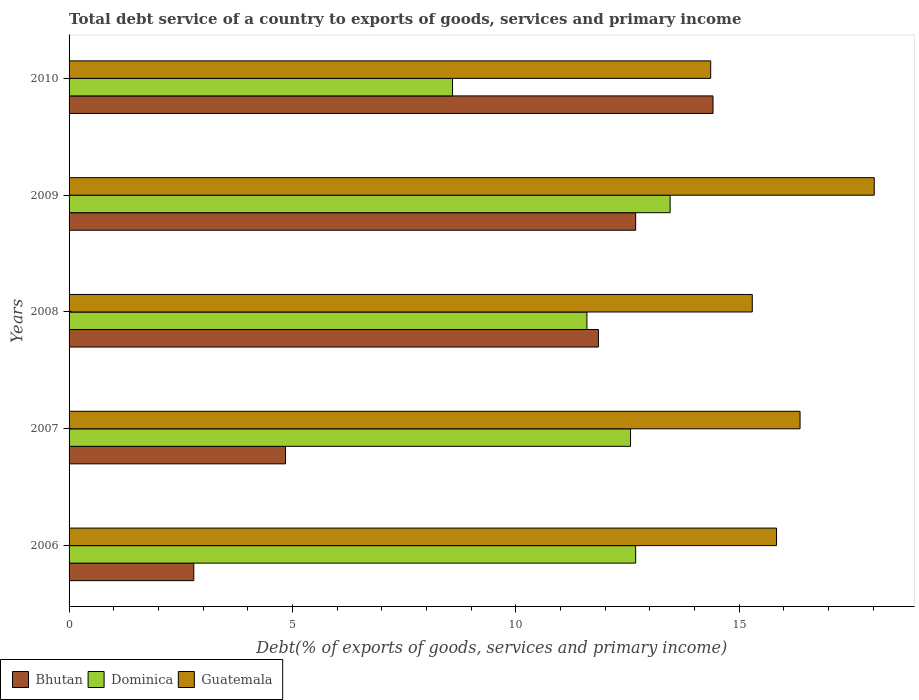Are the number of bars per tick equal to the number of legend labels?
Provide a short and direct response. Yes. Are the number of bars on each tick of the Y-axis equal?
Provide a succinct answer. Yes. How many bars are there on the 3rd tick from the bottom?
Your response must be concise. 3. What is the label of the 4th group of bars from the top?
Offer a very short reply. 2007. What is the total debt service in Dominica in 2007?
Offer a very short reply. 12.57. Across all years, what is the maximum total debt service in Bhutan?
Provide a succinct answer. 14.42. Across all years, what is the minimum total debt service in Bhutan?
Keep it short and to the point. 2.79. In which year was the total debt service in Dominica maximum?
Ensure brevity in your answer.  2009. What is the total total debt service in Bhutan in the graph?
Offer a terse response. 46.59. What is the difference between the total debt service in Dominica in 2008 and that in 2009?
Give a very brief answer. -1.86. What is the difference between the total debt service in Bhutan in 2009 and the total debt service in Guatemala in 2007?
Provide a short and direct response. -3.68. What is the average total debt service in Dominica per year?
Offer a very short reply. 11.78. In the year 2007, what is the difference between the total debt service in Bhutan and total debt service in Dominica?
Provide a succinct answer. -7.72. In how many years, is the total debt service in Guatemala greater than 14 %?
Your response must be concise. 5. What is the ratio of the total debt service in Guatemala in 2006 to that in 2008?
Your answer should be very brief. 1.04. What is the difference between the highest and the second highest total debt service in Bhutan?
Ensure brevity in your answer.  1.73. What is the difference between the highest and the lowest total debt service in Bhutan?
Provide a succinct answer. 11.62. In how many years, is the total debt service in Guatemala greater than the average total debt service in Guatemala taken over all years?
Offer a very short reply. 2. Is the sum of the total debt service in Guatemala in 2008 and 2009 greater than the maximum total debt service in Dominica across all years?
Ensure brevity in your answer.  Yes. What does the 2nd bar from the top in 2009 represents?
Offer a very short reply. Dominica. What does the 3rd bar from the bottom in 2008 represents?
Give a very brief answer. Guatemala. Is it the case that in every year, the sum of the total debt service in Bhutan and total debt service in Dominica is greater than the total debt service in Guatemala?
Your response must be concise. No. How many bars are there?
Offer a terse response. 15. Are all the bars in the graph horizontal?
Ensure brevity in your answer.  Yes. How many years are there in the graph?
Give a very brief answer. 5. What is the difference between two consecutive major ticks on the X-axis?
Your response must be concise. 5. Does the graph contain any zero values?
Your answer should be compact. No. Does the graph contain grids?
Your answer should be compact. No. Where does the legend appear in the graph?
Make the answer very short. Bottom left. What is the title of the graph?
Offer a very short reply. Total debt service of a country to exports of goods, services and primary income. What is the label or title of the X-axis?
Offer a terse response. Debt(% of exports of goods, services and primary income). What is the Debt(% of exports of goods, services and primary income) in Bhutan in 2006?
Provide a succinct answer. 2.79. What is the Debt(% of exports of goods, services and primary income) in Dominica in 2006?
Ensure brevity in your answer.  12.68. What is the Debt(% of exports of goods, services and primary income) of Guatemala in 2006?
Provide a short and direct response. 15.84. What is the Debt(% of exports of goods, services and primary income) of Bhutan in 2007?
Give a very brief answer. 4.85. What is the Debt(% of exports of goods, services and primary income) in Dominica in 2007?
Your answer should be very brief. 12.57. What is the Debt(% of exports of goods, services and primary income) of Guatemala in 2007?
Your answer should be compact. 16.36. What is the Debt(% of exports of goods, services and primary income) in Bhutan in 2008?
Your answer should be very brief. 11.85. What is the Debt(% of exports of goods, services and primary income) of Dominica in 2008?
Provide a short and direct response. 11.59. What is the Debt(% of exports of goods, services and primary income) of Guatemala in 2008?
Give a very brief answer. 15.3. What is the Debt(% of exports of goods, services and primary income) of Bhutan in 2009?
Offer a terse response. 12.68. What is the Debt(% of exports of goods, services and primary income) of Dominica in 2009?
Your response must be concise. 13.46. What is the Debt(% of exports of goods, services and primary income) in Guatemala in 2009?
Provide a short and direct response. 18.03. What is the Debt(% of exports of goods, services and primary income) of Bhutan in 2010?
Offer a terse response. 14.42. What is the Debt(% of exports of goods, services and primary income) of Dominica in 2010?
Your response must be concise. 8.58. What is the Debt(% of exports of goods, services and primary income) of Guatemala in 2010?
Make the answer very short. 14.36. Across all years, what is the maximum Debt(% of exports of goods, services and primary income) in Bhutan?
Provide a succinct answer. 14.42. Across all years, what is the maximum Debt(% of exports of goods, services and primary income) in Dominica?
Your answer should be very brief. 13.46. Across all years, what is the maximum Debt(% of exports of goods, services and primary income) of Guatemala?
Ensure brevity in your answer.  18.03. Across all years, what is the minimum Debt(% of exports of goods, services and primary income) of Bhutan?
Provide a succinct answer. 2.79. Across all years, what is the minimum Debt(% of exports of goods, services and primary income) of Dominica?
Your answer should be very brief. 8.58. Across all years, what is the minimum Debt(% of exports of goods, services and primary income) of Guatemala?
Your answer should be very brief. 14.36. What is the total Debt(% of exports of goods, services and primary income) in Bhutan in the graph?
Your answer should be very brief. 46.59. What is the total Debt(% of exports of goods, services and primary income) of Dominica in the graph?
Your answer should be compact. 58.89. What is the total Debt(% of exports of goods, services and primary income) in Guatemala in the graph?
Offer a terse response. 79.89. What is the difference between the Debt(% of exports of goods, services and primary income) of Bhutan in 2006 and that in 2007?
Keep it short and to the point. -2.05. What is the difference between the Debt(% of exports of goods, services and primary income) of Dominica in 2006 and that in 2007?
Offer a very short reply. 0.11. What is the difference between the Debt(% of exports of goods, services and primary income) of Guatemala in 2006 and that in 2007?
Provide a succinct answer. -0.53. What is the difference between the Debt(% of exports of goods, services and primary income) of Bhutan in 2006 and that in 2008?
Your answer should be compact. -9.06. What is the difference between the Debt(% of exports of goods, services and primary income) of Guatemala in 2006 and that in 2008?
Your answer should be very brief. 0.54. What is the difference between the Debt(% of exports of goods, services and primary income) of Bhutan in 2006 and that in 2009?
Your response must be concise. -9.89. What is the difference between the Debt(% of exports of goods, services and primary income) of Dominica in 2006 and that in 2009?
Offer a very short reply. -0.77. What is the difference between the Debt(% of exports of goods, services and primary income) in Guatemala in 2006 and that in 2009?
Make the answer very short. -2.19. What is the difference between the Debt(% of exports of goods, services and primary income) in Bhutan in 2006 and that in 2010?
Keep it short and to the point. -11.62. What is the difference between the Debt(% of exports of goods, services and primary income) in Dominica in 2006 and that in 2010?
Your answer should be very brief. 4.1. What is the difference between the Debt(% of exports of goods, services and primary income) in Guatemala in 2006 and that in 2010?
Provide a short and direct response. 1.47. What is the difference between the Debt(% of exports of goods, services and primary income) in Bhutan in 2007 and that in 2008?
Ensure brevity in your answer.  -7. What is the difference between the Debt(% of exports of goods, services and primary income) in Dominica in 2007 and that in 2008?
Offer a terse response. 0.98. What is the difference between the Debt(% of exports of goods, services and primary income) of Guatemala in 2007 and that in 2008?
Provide a short and direct response. 1.07. What is the difference between the Debt(% of exports of goods, services and primary income) in Bhutan in 2007 and that in 2009?
Give a very brief answer. -7.84. What is the difference between the Debt(% of exports of goods, services and primary income) of Dominica in 2007 and that in 2009?
Your answer should be very brief. -0.89. What is the difference between the Debt(% of exports of goods, services and primary income) of Guatemala in 2007 and that in 2009?
Ensure brevity in your answer.  -1.66. What is the difference between the Debt(% of exports of goods, services and primary income) of Bhutan in 2007 and that in 2010?
Keep it short and to the point. -9.57. What is the difference between the Debt(% of exports of goods, services and primary income) of Dominica in 2007 and that in 2010?
Offer a terse response. 3.99. What is the difference between the Debt(% of exports of goods, services and primary income) of Guatemala in 2007 and that in 2010?
Provide a short and direct response. 2. What is the difference between the Debt(% of exports of goods, services and primary income) in Bhutan in 2008 and that in 2009?
Provide a short and direct response. -0.83. What is the difference between the Debt(% of exports of goods, services and primary income) in Dominica in 2008 and that in 2009?
Provide a short and direct response. -1.86. What is the difference between the Debt(% of exports of goods, services and primary income) of Guatemala in 2008 and that in 2009?
Your answer should be very brief. -2.73. What is the difference between the Debt(% of exports of goods, services and primary income) of Bhutan in 2008 and that in 2010?
Make the answer very short. -2.57. What is the difference between the Debt(% of exports of goods, services and primary income) of Dominica in 2008 and that in 2010?
Your answer should be very brief. 3.01. What is the difference between the Debt(% of exports of goods, services and primary income) of Guatemala in 2008 and that in 2010?
Your answer should be very brief. 0.93. What is the difference between the Debt(% of exports of goods, services and primary income) in Bhutan in 2009 and that in 2010?
Your response must be concise. -1.73. What is the difference between the Debt(% of exports of goods, services and primary income) in Dominica in 2009 and that in 2010?
Make the answer very short. 4.87. What is the difference between the Debt(% of exports of goods, services and primary income) of Guatemala in 2009 and that in 2010?
Offer a very short reply. 3.66. What is the difference between the Debt(% of exports of goods, services and primary income) in Bhutan in 2006 and the Debt(% of exports of goods, services and primary income) in Dominica in 2007?
Your answer should be compact. -9.78. What is the difference between the Debt(% of exports of goods, services and primary income) in Bhutan in 2006 and the Debt(% of exports of goods, services and primary income) in Guatemala in 2007?
Your response must be concise. -13.57. What is the difference between the Debt(% of exports of goods, services and primary income) in Dominica in 2006 and the Debt(% of exports of goods, services and primary income) in Guatemala in 2007?
Your answer should be very brief. -3.68. What is the difference between the Debt(% of exports of goods, services and primary income) of Bhutan in 2006 and the Debt(% of exports of goods, services and primary income) of Dominica in 2008?
Your answer should be very brief. -8.8. What is the difference between the Debt(% of exports of goods, services and primary income) of Bhutan in 2006 and the Debt(% of exports of goods, services and primary income) of Guatemala in 2008?
Offer a terse response. -12.5. What is the difference between the Debt(% of exports of goods, services and primary income) in Dominica in 2006 and the Debt(% of exports of goods, services and primary income) in Guatemala in 2008?
Your response must be concise. -2.61. What is the difference between the Debt(% of exports of goods, services and primary income) of Bhutan in 2006 and the Debt(% of exports of goods, services and primary income) of Dominica in 2009?
Your response must be concise. -10.66. What is the difference between the Debt(% of exports of goods, services and primary income) of Bhutan in 2006 and the Debt(% of exports of goods, services and primary income) of Guatemala in 2009?
Give a very brief answer. -15.23. What is the difference between the Debt(% of exports of goods, services and primary income) in Dominica in 2006 and the Debt(% of exports of goods, services and primary income) in Guatemala in 2009?
Keep it short and to the point. -5.34. What is the difference between the Debt(% of exports of goods, services and primary income) in Bhutan in 2006 and the Debt(% of exports of goods, services and primary income) in Dominica in 2010?
Your response must be concise. -5.79. What is the difference between the Debt(% of exports of goods, services and primary income) of Bhutan in 2006 and the Debt(% of exports of goods, services and primary income) of Guatemala in 2010?
Your answer should be very brief. -11.57. What is the difference between the Debt(% of exports of goods, services and primary income) of Dominica in 2006 and the Debt(% of exports of goods, services and primary income) of Guatemala in 2010?
Your answer should be very brief. -1.68. What is the difference between the Debt(% of exports of goods, services and primary income) in Bhutan in 2007 and the Debt(% of exports of goods, services and primary income) in Dominica in 2008?
Give a very brief answer. -6.75. What is the difference between the Debt(% of exports of goods, services and primary income) of Bhutan in 2007 and the Debt(% of exports of goods, services and primary income) of Guatemala in 2008?
Your answer should be compact. -10.45. What is the difference between the Debt(% of exports of goods, services and primary income) in Dominica in 2007 and the Debt(% of exports of goods, services and primary income) in Guatemala in 2008?
Provide a succinct answer. -2.73. What is the difference between the Debt(% of exports of goods, services and primary income) in Bhutan in 2007 and the Debt(% of exports of goods, services and primary income) in Dominica in 2009?
Your answer should be very brief. -8.61. What is the difference between the Debt(% of exports of goods, services and primary income) in Bhutan in 2007 and the Debt(% of exports of goods, services and primary income) in Guatemala in 2009?
Provide a succinct answer. -13.18. What is the difference between the Debt(% of exports of goods, services and primary income) of Dominica in 2007 and the Debt(% of exports of goods, services and primary income) of Guatemala in 2009?
Your answer should be compact. -5.46. What is the difference between the Debt(% of exports of goods, services and primary income) in Bhutan in 2007 and the Debt(% of exports of goods, services and primary income) in Dominica in 2010?
Provide a succinct answer. -3.74. What is the difference between the Debt(% of exports of goods, services and primary income) of Bhutan in 2007 and the Debt(% of exports of goods, services and primary income) of Guatemala in 2010?
Your response must be concise. -9.52. What is the difference between the Debt(% of exports of goods, services and primary income) of Dominica in 2007 and the Debt(% of exports of goods, services and primary income) of Guatemala in 2010?
Your answer should be compact. -1.79. What is the difference between the Debt(% of exports of goods, services and primary income) in Bhutan in 2008 and the Debt(% of exports of goods, services and primary income) in Dominica in 2009?
Provide a succinct answer. -1.61. What is the difference between the Debt(% of exports of goods, services and primary income) of Bhutan in 2008 and the Debt(% of exports of goods, services and primary income) of Guatemala in 2009?
Offer a terse response. -6.18. What is the difference between the Debt(% of exports of goods, services and primary income) of Dominica in 2008 and the Debt(% of exports of goods, services and primary income) of Guatemala in 2009?
Provide a short and direct response. -6.43. What is the difference between the Debt(% of exports of goods, services and primary income) in Bhutan in 2008 and the Debt(% of exports of goods, services and primary income) in Dominica in 2010?
Offer a very short reply. 3.27. What is the difference between the Debt(% of exports of goods, services and primary income) in Bhutan in 2008 and the Debt(% of exports of goods, services and primary income) in Guatemala in 2010?
Your answer should be very brief. -2.51. What is the difference between the Debt(% of exports of goods, services and primary income) in Dominica in 2008 and the Debt(% of exports of goods, services and primary income) in Guatemala in 2010?
Give a very brief answer. -2.77. What is the difference between the Debt(% of exports of goods, services and primary income) in Bhutan in 2009 and the Debt(% of exports of goods, services and primary income) in Dominica in 2010?
Provide a succinct answer. 4.1. What is the difference between the Debt(% of exports of goods, services and primary income) of Bhutan in 2009 and the Debt(% of exports of goods, services and primary income) of Guatemala in 2010?
Offer a very short reply. -1.68. What is the difference between the Debt(% of exports of goods, services and primary income) in Dominica in 2009 and the Debt(% of exports of goods, services and primary income) in Guatemala in 2010?
Give a very brief answer. -0.91. What is the average Debt(% of exports of goods, services and primary income) of Bhutan per year?
Offer a very short reply. 9.32. What is the average Debt(% of exports of goods, services and primary income) of Dominica per year?
Provide a short and direct response. 11.78. What is the average Debt(% of exports of goods, services and primary income) in Guatemala per year?
Make the answer very short. 15.98. In the year 2006, what is the difference between the Debt(% of exports of goods, services and primary income) of Bhutan and Debt(% of exports of goods, services and primary income) of Dominica?
Your answer should be compact. -9.89. In the year 2006, what is the difference between the Debt(% of exports of goods, services and primary income) in Bhutan and Debt(% of exports of goods, services and primary income) in Guatemala?
Keep it short and to the point. -13.05. In the year 2006, what is the difference between the Debt(% of exports of goods, services and primary income) of Dominica and Debt(% of exports of goods, services and primary income) of Guatemala?
Provide a succinct answer. -3.15. In the year 2007, what is the difference between the Debt(% of exports of goods, services and primary income) of Bhutan and Debt(% of exports of goods, services and primary income) of Dominica?
Provide a short and direct response. -7.72. In the year 2007, what is the difference between the Debt(% of exports of goods, services and primary income) of Bhutan and Debt(% of exports of goods, services and primary income) of Guatemala?
Offer a very short reply. -11.52. In the year 2007, what is the difference between the Debt(% of exports of goods, services and primary income) of Dominica and Debt(% of exports of goods, services and primary income) of Guatemala?
Ensure brevity in your answer.  -3.79. In the year 2008, what is the difference between the Debt(% of exports of goods, services and primary income) in Bhutan and Debt(% of exports of goods, services and primary income) in Dominica?
Your response must be concise. 0.26. In the year 2008, what is the difference between the Debt(% of exports of goods, services and primary income) of Bhutan and Debt(% of exports of goods, services and primary income) of Guatemala?
Give a very brief answer. -3.44. In the year 2008, what is the difference between the Debt(% of exports of goods, services and primary income) in Dominica and Debt(% of exports of goods, services and primary income) in Guatemala?
Your answer should be compact. -3.7. In the year 2009, what is the difference between the Debt(% of exports of goods, services and primary income) in Bhutan and Debt(% of exports of goods, services and primary income) in Dominica?
Offer a very short reply. -0.77. In the year 2009, what is the difference between the Debt(% of exports of goods, services and primary income) of Bhutan and Debt(% of exports of goods, services and primary income) of Guatemala?
Your answer should be very brief. -5.34. In the year 2009, what is the difference between the Debt(% of exports of goods, services and primary income) in Dominica and Debt(% of exports of goods, services and primary income) in Guatemala?
Your response must be concise. -4.57. In the year 2010, what is the difference between the Debt(% of exports of goods, services and primary income) in Bhutan and Debt(% of exports of goods, services and primary income) in Dominica?
Provide a succinct answer. 5.83. In the year 2010, what is the difference between the Debt(% of exports of goods, services and primary income) of Bhutan and Debt(% of exports of goods, services and primary income) of Guatemala?
Your response must be concise. 0.05. In the year 2010, what is the difference between the Debt(% of exports of goods, services and primary income) of Dominica and Debt(% of exports of goods, services and primary income) of Guatemala?
Ensure brevity in your answer.  -5.78. What is the ratio of the Debt(% of exports of goods, services and primary income) of Bhutan in 2006 to that in 2007?
Give a very brief answer. 0.58. What is the ratio of the Debt(% of exports of goods, services and primary income) in Dominica in 2006 to that in 2007?
Your answer should be compact. 1.01. What is the ratio of the Debt(% of exports of goods, services and primary income) of Guatemala in 2006 to that in 2007?
Your answer should be very brief. 0.97. What is the ratio of the Debt(% of exports of goods, services and primary income) of Bhutan in 2006 to that in 2008?
Your answer should be very brief. 0.24. What is the ratio of the Debt(% of exports of goods, services and primary income) in Dominica in 2006 to that in 2008?
Provide a succinct answer. 1.09. What is the ratio of the Debt(% of exports of goods, services and primary income) of Guatemala in 2006 to that in 2008?
Offer a very short reply. 1.04. What is the ratio of the Debt(% of exports of goods, services and primary income) in Bhutan in 2006 to that in 2009?
Your answer should be very brief. 0.22. What is the ratio of the Debt(% of exports of goods, services and primary income) of Dominica in 2006 to that in 2009?
Provide a succinct answer. 0.94. What is the ratio of the Debt(% of exports of goods, services and primary income) of Guatemala in 2006 to that in 2009?
Offer a terse response. 0.88. What is the ratio of the Debt(% of exports of goods, services and primary income) of Bhutan in 2006 to that in 2010?
Offer a terse response. 0.19. What is the ratio of the Debt(% of exports of goods, services and primary income) in Dominica in 2006 to that in 2010?
Give a very brief answer. 1.48. What is the ratio of the Debt(% of exports of goods, services and primary income) in Guatemala in 2006 to that in 2010?
Make the answer very short. 1.1. What is the ratio of the Debt(% of exports of goods, services and primary income) of Bhutan in 2007 to that in 2008?
Ensure brevity in your answer.  0.41. What is the ratio of the Debt(% of exports of goods, services and primary income) in Dominica in 2007 to that in 2008?
Make the answer very short. 1.08. What is the ratio of the Debt(% of exports of goods, services and primary income) of Guatemala in 2007 to that in 2008?
Ensure brevity in your answer.  1.07. What is the ratio of the Debt(% of exports of goods, services and primary income) of Bhutan in 2007 to that in 2009?
Your response must be concise. 0.38. What is the ratio of the Debt(% of exports of goods, services and primary income) of Dominica in 2007 to that in 2009?
Provide a short and direct response. 0.93. What is the ratio of the Debt(% of exports of goods, services and primary income) of Guatemala in 2007 to that in 2009?
Your response must be concise. 0.91. What is the ratio of the Debt(% of exports of goods, services and primary income) in Bhutan in 2007 to that in 2010?
Provide a short and direct response. 0.34. What is the ratio of the Debt(% of exports of goods, services and primary income) of Dominica in 2007 to that in 2010?
Keep it short and to the point. 1.46. What is the ratio of the Debt(% of exports of goods, services and primary income) of Guatemala in 2007 to that in 2010?
Give a very brief answer. 1.14. What is the ratio of the Debt(% of exports of goods, services and primary income) of Bhutan in 2008 to that in 2009?
Keep it short and to the point. 0.93. What is the ratio of the Debt(% of exports of goods, services and primary income) in Dominica in 2008 to that in 2009?
Ensure brevity in your answer.  0.86. What is the ratio of the Debt(% of exports of goods, services and primary income) of Guatemala in 2008 to that in 2009?
Offer a terse response. 0.85. What is the ratio of the Debt(% of exports of goods, services and primary income) in Bhutan in 2008 to that in 2010?
Give a very brief answer. 0.82. What is the ratio of the Debt(% of exports of goods, services and primary income) in Dominica in 2008 to that in 2010?
Your answer should be very brief. 1.35. What is the ratio of the Debt(% of exports of goods, services and primary income) of Guatemala in 2008 to that in 2010?
Keep it short and to the point. 1.06. What is the ratio of the Debt(% of exports of goods, services and primary income) of Bhutan in 2009 to that in 2010?
Give a very brief answer. 0.88. What is the ratio of the Debt(% of exports of goods, services and primary income) in Dominica in 2009 to that in 2010?
Offer a very short reply. 1.57. What is the ratio of the Debt(% of exports of goods, services and primary income) of Guatemala in 2009 to that in 2010?
Provide a succinct answer. 1.25. What is the difference between the highest and the second highest Debt(% of exports of goods, services and primary income) in Bhutan?
Keep it short and to the point. 1.73. What is the difference between the highest and the second highest Debt(% of exports of goods, services and primary income) in Dominica?
Your answer should be very brief. 0.77. What is the difference between the highest and the second highest Debt(% of exports of goods, services and primary income) of Guatemala?
Keep it short and to the point. 1.66. What is the difference between the highest and the lowest Debt(% of exports of goods, services and primary income) of Bhutan?
Provide a short and direct response. 11.62. What is the difference between the highest and the lowest Debt(% of exports of goods, services and primary income) of Dominica?
Offer a very short reply. 4.87. What is the difference between the highest and the lowest Debt(% of exports of goods, services and primary income) in Guatemala?
Your response must be concise. 3.66. 